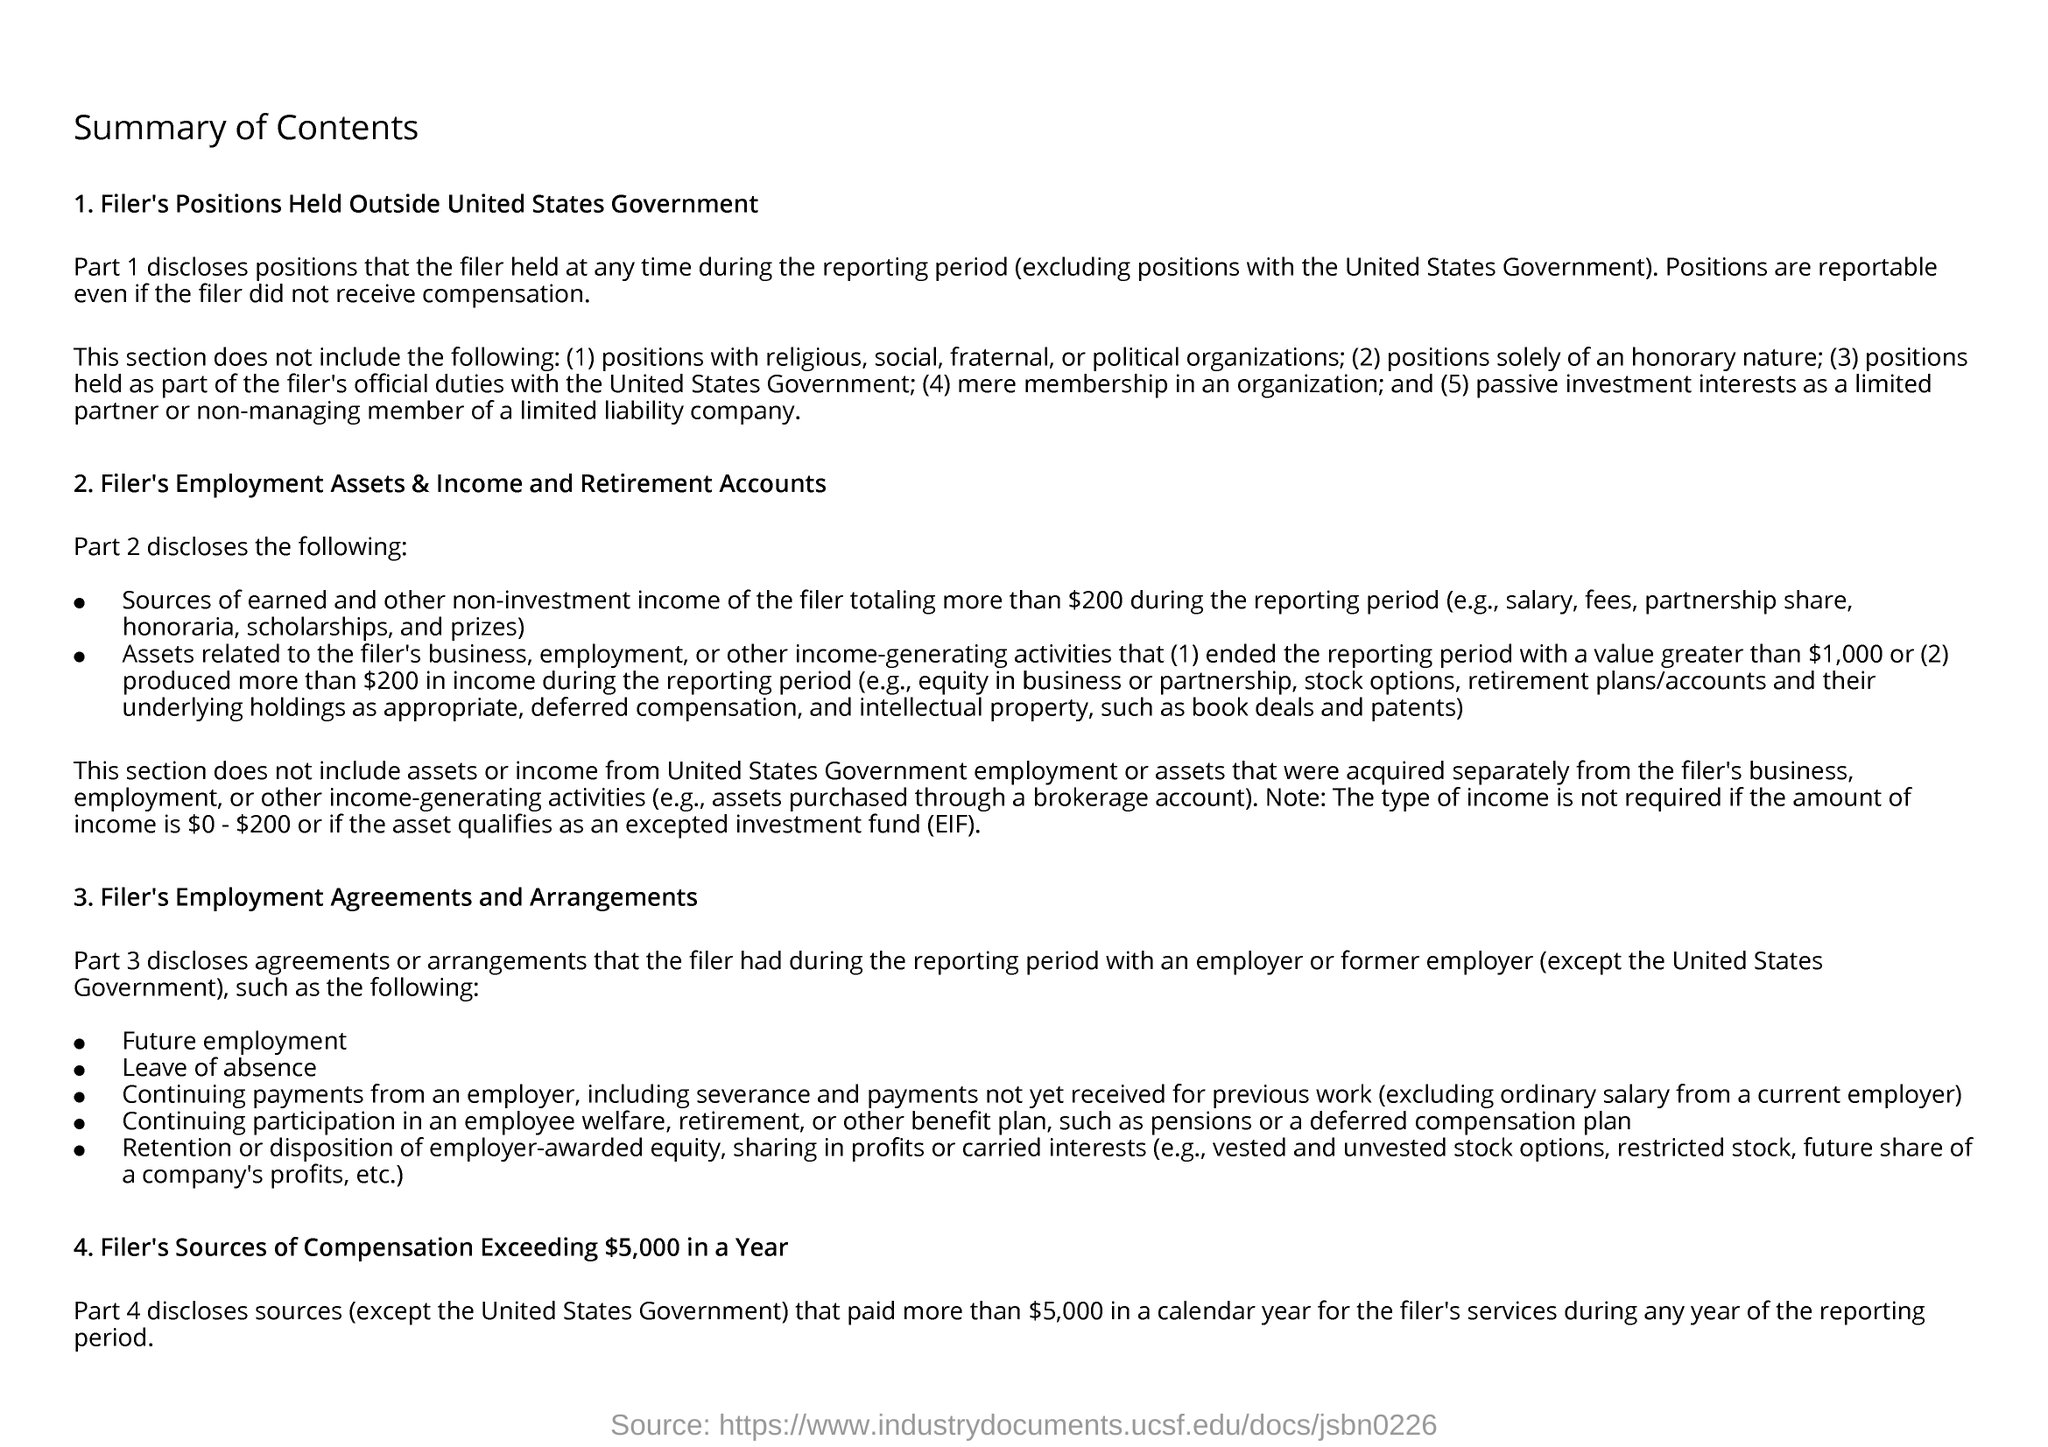Which part discloses agreements or arrangements that the filer had during the reporting period with an employer or former employer?
Provide a succinct answer. PART 3. Which part discloses the positions that the filer held at any time during the reporting period?
Make the answer very short. Part 1. What does EIF stand for?
Your answer should be compact. Excepted Investment Fund. 